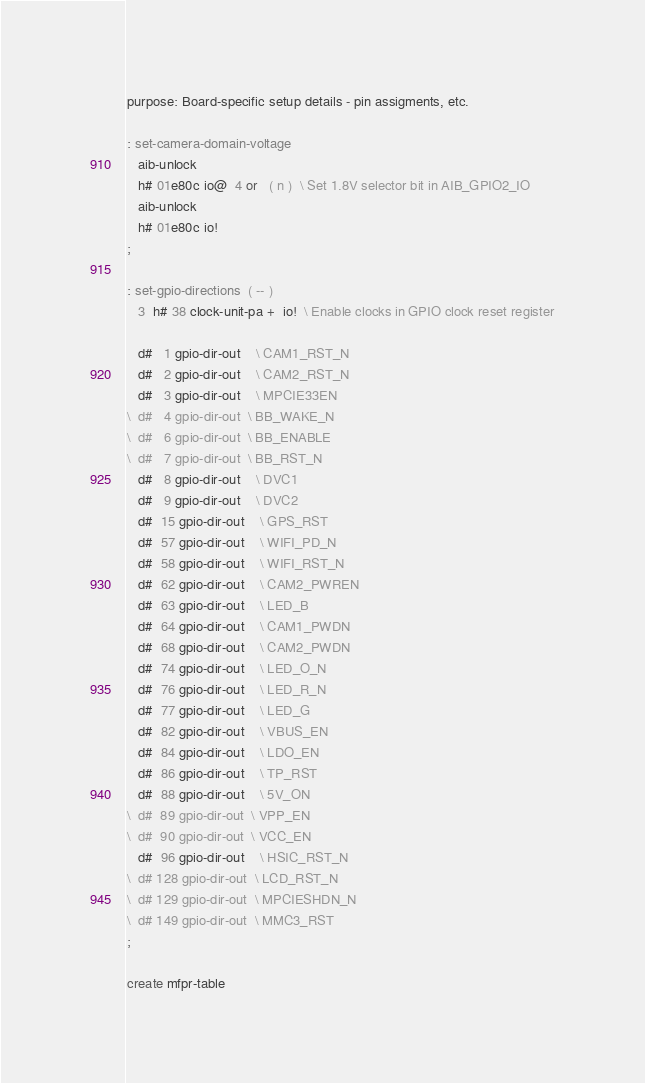Convert code to text. <code><loc_0><loc_0><loc_500><loc_500><_Forth_>purpose: Board-specific setup details - pin assigments, etc.

: set-camera-domain-voltage
   aib-unlock
   h# 01e80c io@  4 or   ( n )  \ Set 1.8V selector bit in AIB_GPIO2_IO
   aib-unlock
   h# 01e80c io!
;

: set-gpio-directions  ( -- )
   3  h# 38 clock-unit-pa +  io!  \ Enable clocks in GPIO clock reset register

   d#   1 gpio-dir-out	\ CAM1_RST_N
   d#   2 gpio-dir-out	\ CAM2_RST_N
   d#   3 gpio-dir-out	\ MPCIE33EN
\  d#   4 gpio-dir-out	\ BB_WAKE_N
\  d#   6 gpio-dir-out	\ BB_ENABLE
\  d#   7 gpio-dir-out	\ BB_RST_N
   d#   8 gpio-dir-out	\ DVC1
   d#   9 gpio-dir-out	\ DVC2
   d#  15 gpio-dir-out	\ GPS_RST
   d#  57 gpio-dir-out	\ WIFI_PD_N
   d#  58 gpio-dir-out	\ WIFI_RST_N
   d#  62 gpio-dir-out	\ CAM2_PWREN
   d#  63 gpio-dir-out	\ LED_B
   d#  64 gpio-dir-out	\ CAM1_PWDN
   d#  68 gpio-dir-out	\ CAM2_PWDN
   d#  74 gpio-dir-out	\ LED_O_N
   d#  76 gpio-dir-out	\ LED_R_N
   d#  77 gpio-dir-out	\ LED_G
   d#  82 gpio-dir-out	\ VBUS_EN
   d#  84 gpio-dir-out	\ LDO_EN
   d#  86 gpio-dir-out	\ TP_RST
   d#  88 gpio-dir-out	\ 5V_ON
\  d#  89 gpio-dir-out	\ VPP_EN
\  d#  90 gpio-dir-out	\ VCC_EN
   d#  96 gpio-dir-out	\ HSIC_RST_N
\  d# 128 gpio-dir-out	\ LCD_RST_N
\  d# 129 gpio-dir-out	\ MPCIESHDN_N
\  d# 149 gpio-dir-out	\ MMC3_RST
;

create mfpr-table</code> 